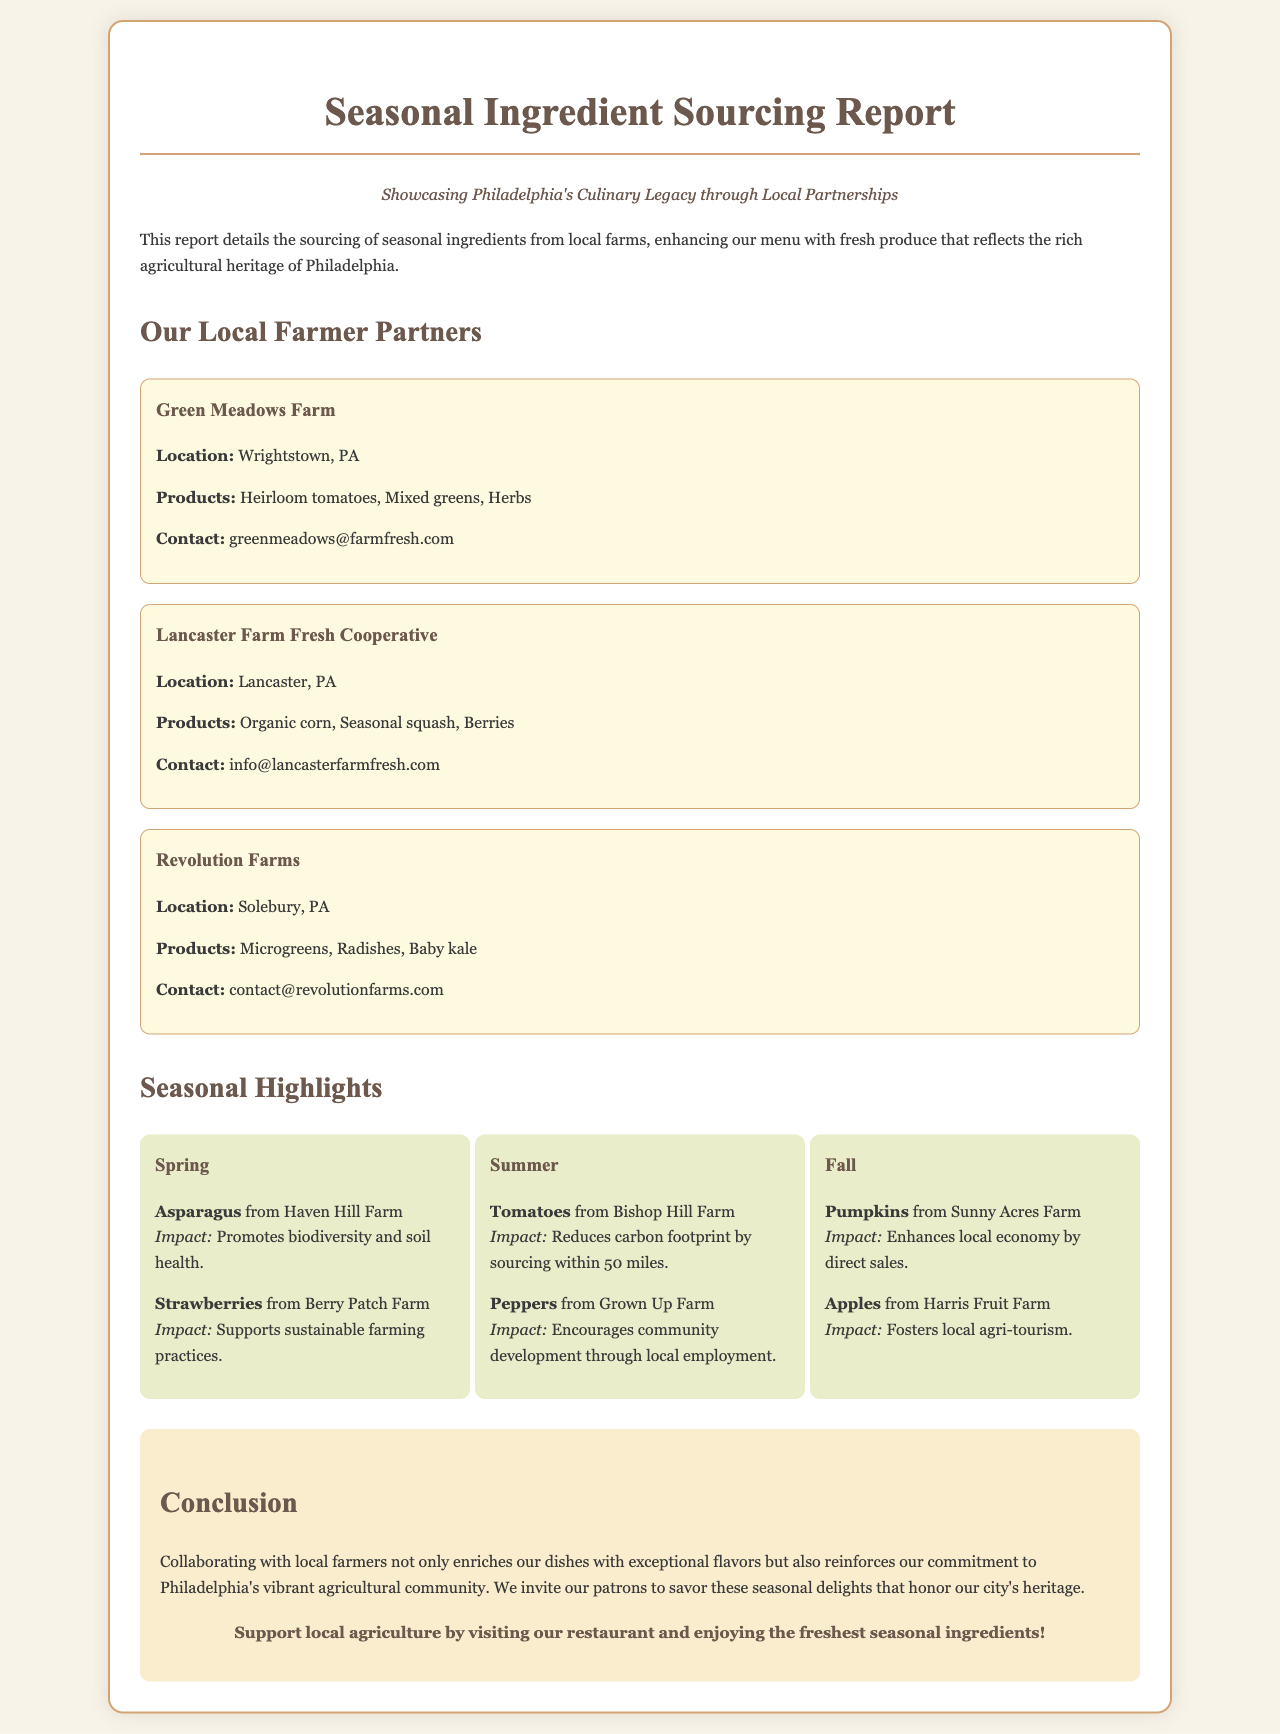What is the title of the report? The title of the report is prominently displayed at the top of the document.
Answer: Seasonal Ingredient Sourcing Report Who is one of the local farmer partners mentioned? The document lists several local farmer partners in specific sections.
Answer: Green Meadows Farm What product is sourced from Lancaster Farm Fresh Cooperative? The report specifies products sourced from each farmer partner.
Answer: Organic corn What season features strawberries in the highlights? The seasonal highlights section outlines the products available during each season.
Answer: Spring What impact do tomatoes from Bishop Hill Farm have? The impact of products is noted in the seasonal highlight section for summer.
Answer: Reduces carbon footprint by sourcing within 50 miles How many local farmer partners are there? The report lists the number of farmer partners included in the document.
Answer: Three What is the main focus of the conclusion section? The conclusion summarizes the key highlights and purpose of collaborating with local farmers.
Answer: Commitment to Philadelphia's vibrant agricultural community What season do pumpkins belong to in the seasonal highlights? The report categorizes products based on the season they are available.
Answer: Fall What is the call to action in the conclusion? The call to action encourages patrons to support local agriculture and visit the restaurant.
Answer: Support local agriculture by visiting our restaurant and enjoying the freshest seasonal ingredients! 